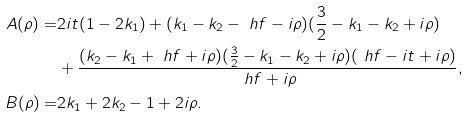Convert formula to latex. <formula><loc_0><loc_0><loc_500><loc_500>A ( \rho ) = & 2 i t ( 1 - 2 k _ { 1 } ) + ( k _ { 1 } - k _ { 2 } - \ h f - i \rho ) ( \frac { 3 } { 2 } - k _ { 1 } - k _ { 2 } + i \rho ) \\ & + \frac { ( k _ { 2 } - k _ { 1 } + \ h f + i \rho ) ( \frac { 3 } { 2 } - k _ { 1 } - k _ { 2 } + i \rho ) ( \ h f - i t + i \rho ) } { \ h f + i \rho } , \\ B ( \rho ) = & 2 k _ { 1 } + 2 k _ { 2 } - 1 + 2 i \rho .</formula> 